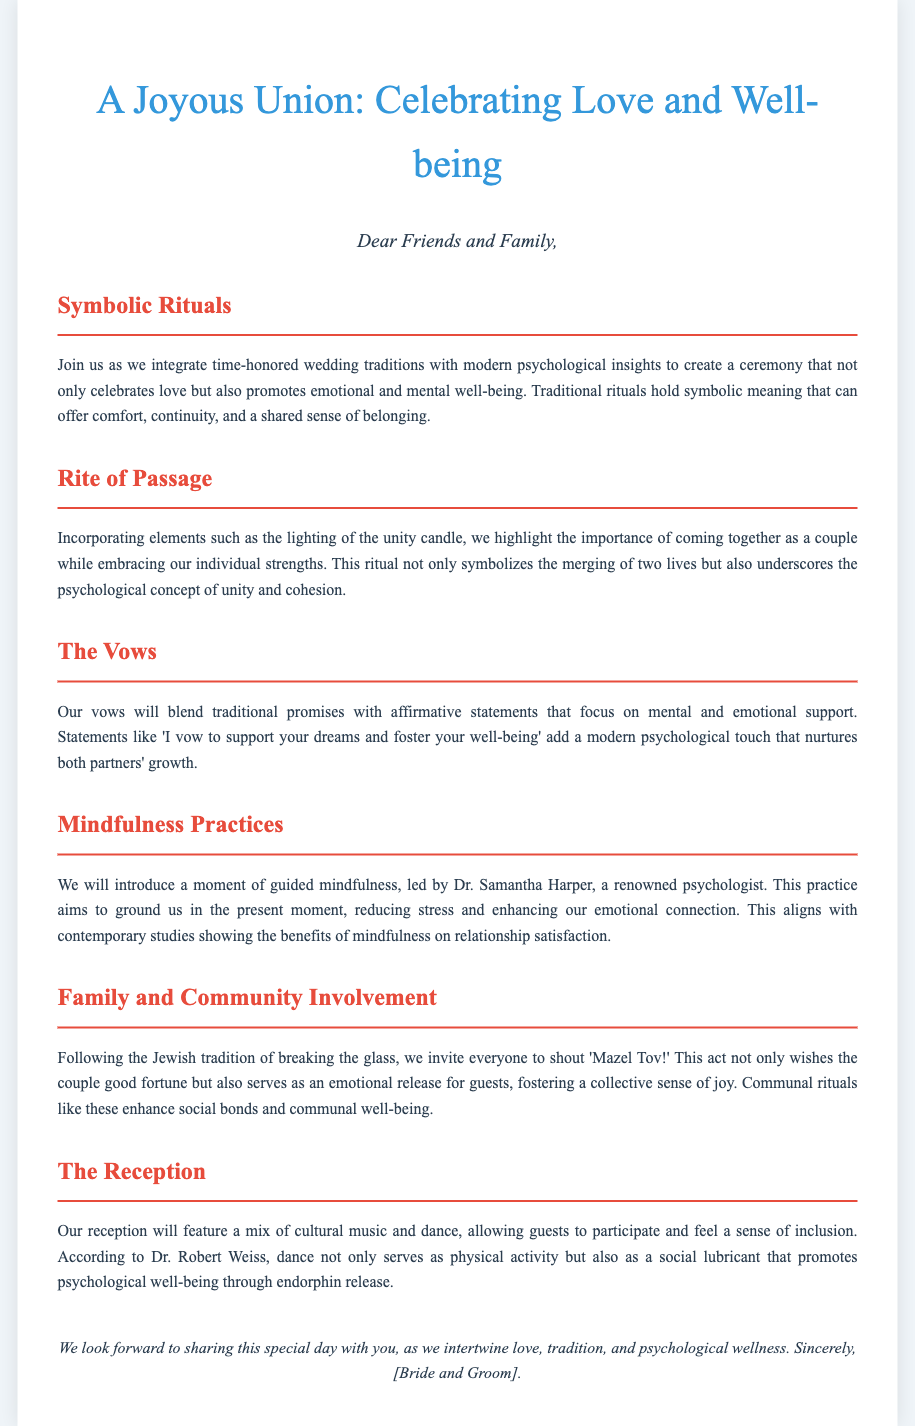What is the title of the event? The title of the event is presented in the header of the document.
Answer: A Joyous Union: Celebrating Love and Well-being Who will lead the moment of guided mindfulness? The document mentions a specific psychologist who will lead this mindfulness practice.
Answer: Dr. Samantha Harper What traditional act is included to wish the couple good fortune? This section describes a Jewish tradition that involves the guests reacting during the ceremony.
Answer: Breaking the glass What psychological concept is highlighted during the lighting of the unity candle? The document identifies a specific psychological concept related to unity and cohesion.
Answer: Unity and cohesion What type of music will be featured at the reception? The document specifies the genre of music included in the reception activities.
Answer: Cultural music What modern touch is added to the couple's vows? The document indicates a specific aspect added to the traditional promises made by the couple.
Answer: Affirmative statements How does the document describe the emotional connection during the mindfulness practice? The document highlights the purpose of introducing mindfulness in relation to emotions.
Answer: Reducing stress and enhancing emotional connection What is the purpose of incorporating communal rituals? The document explains the benefits of including certain rituals for guests.
Answer: Enhance social bonds and communal well-being 